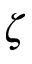Convert formula to latex. <formula><loc_0><loc_0><loc_500><loc_500>\zeta</formula> 